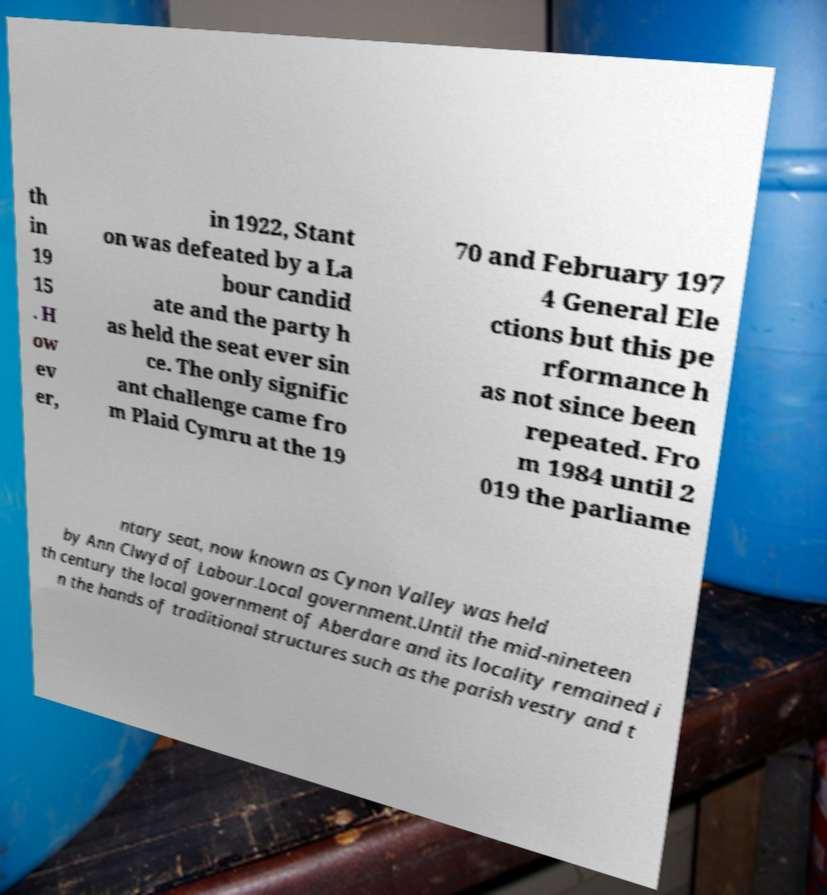I need the written content from this picture converted into text. Can you do that? th in 19 15 . H ow ev er, in 1922, Stant on was defeated by a La bour candid ate and the party h as held the seat ever sin ce. The only signific ant challenge came fro m Plaid Cymru at the 19 70 and February 197 4 General Ele ctions but this pe rformance h as not since been repeated. Fro m 1984 until 2 019 the parliame ntary seat, now known as Cynon Valley was held by Ann Clwyd of Labour.Local government.Until the mid-nineteen th century the local government of Aberdare and its locality remained i n the hands of traditional structures such as the parish vestry and t 